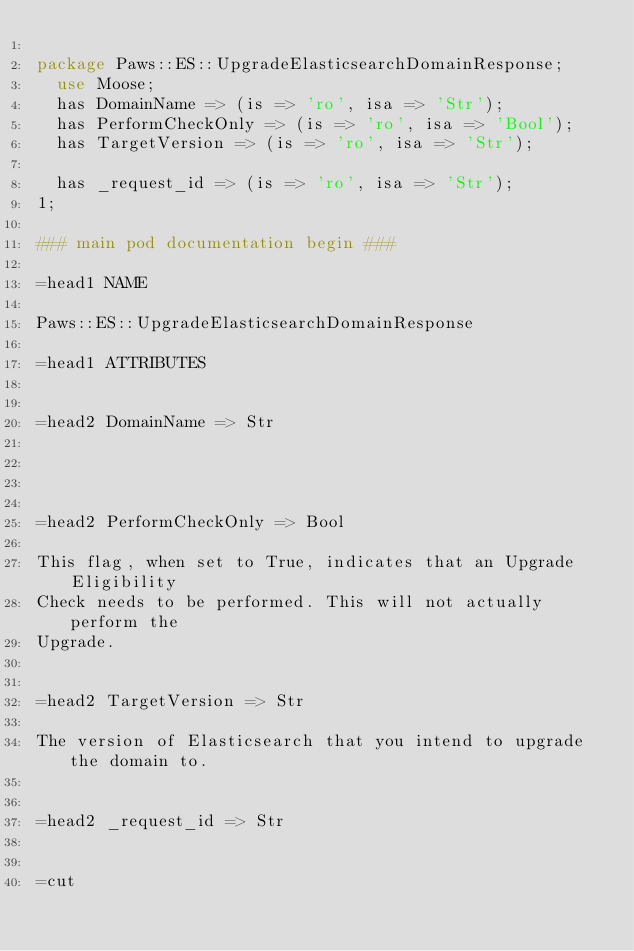<code> <loc_0><loc_0><loc_500><loc_500><_Perl_>
package Paws::ES::UpgradeElasticsearchDomainResponse;
  use Moose;
  has DomainName => (is => 'ro', isa => 'Str');
  has PerformCheckOnly => (is => 'ro', isa => 'Bool');
  has TargetVersion => (is => 'ro', isa => 'Str');

  has _request_id => (is => 'ro', isa => 'Str');
1;

### main pod documentation begin ###

=head1 NAME

Paws::ES::UpgradeElasticsearchDomainResponse

=head1 ATTRIBUTES


=head2 DomainName => Str




=head2 PerformCheckOnly => Bool

This flag, when set to True, indicates that an Upgrade Eligibility
Check needs to be performed. This will not actually perform the
Upgrade.


=head2 TargetVersion => Str

The version of Elasticsearch that you intend to upgrade the domain to.


=head2 _request_id => Str


=cut

</code> 